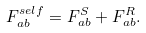Convert formula to latex. <formula><loc_0><loc_0><loc_500><loc_500>F _ { a b } ^ { s e l f } = F _ { a b } ^ { S } + F _ { a b } ^ { R } .</formula> 